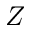Convert formula to latex. <formula><loc_0><loc_0><loc_500><loc_500>Z</formula> 